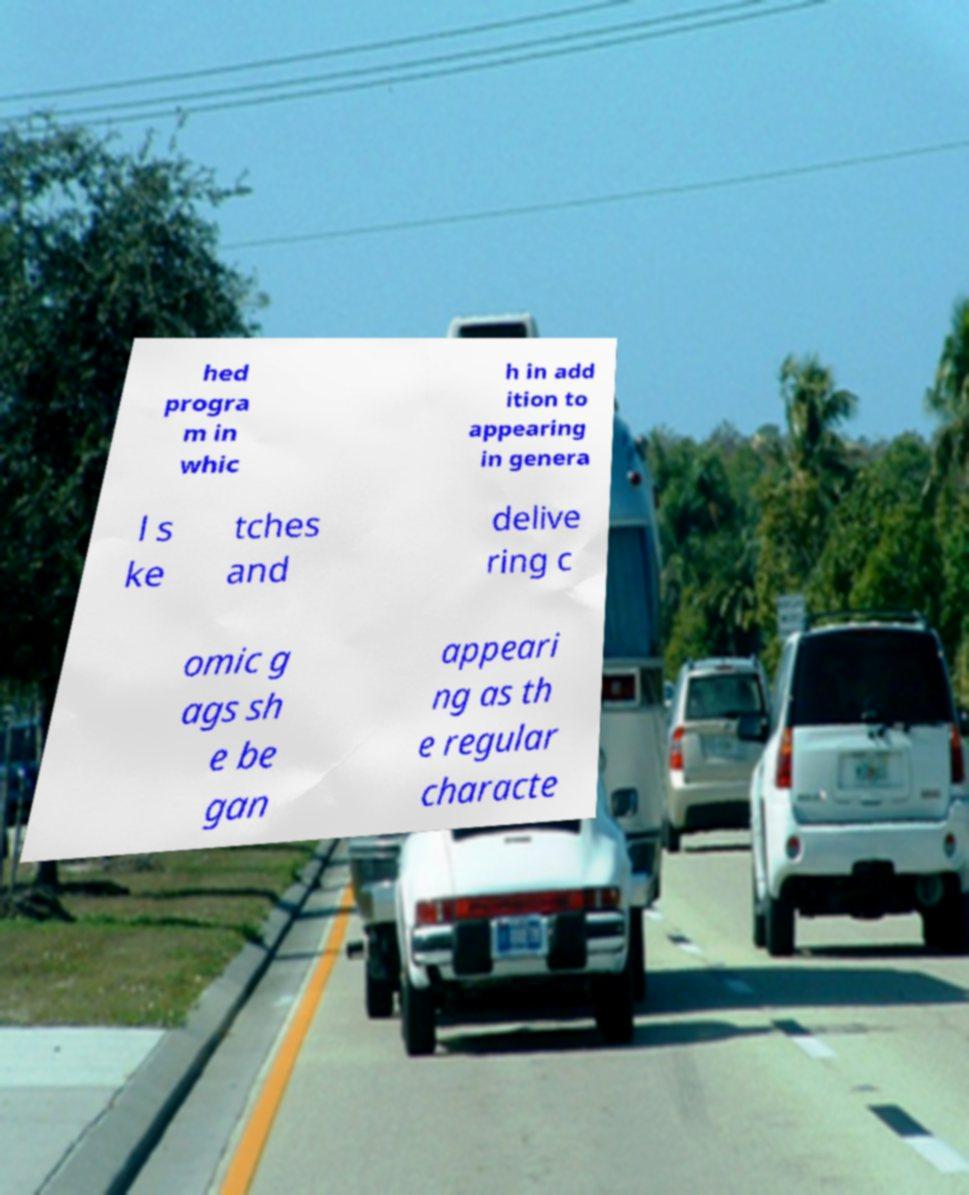Could you assist in decoding the text presented in this image and type it out clearly? hed progra m in whic h in add ition to appearing in genera l s ke tches and delive ring c omic g ags sh e be gan appeari ng as th e regular characte 